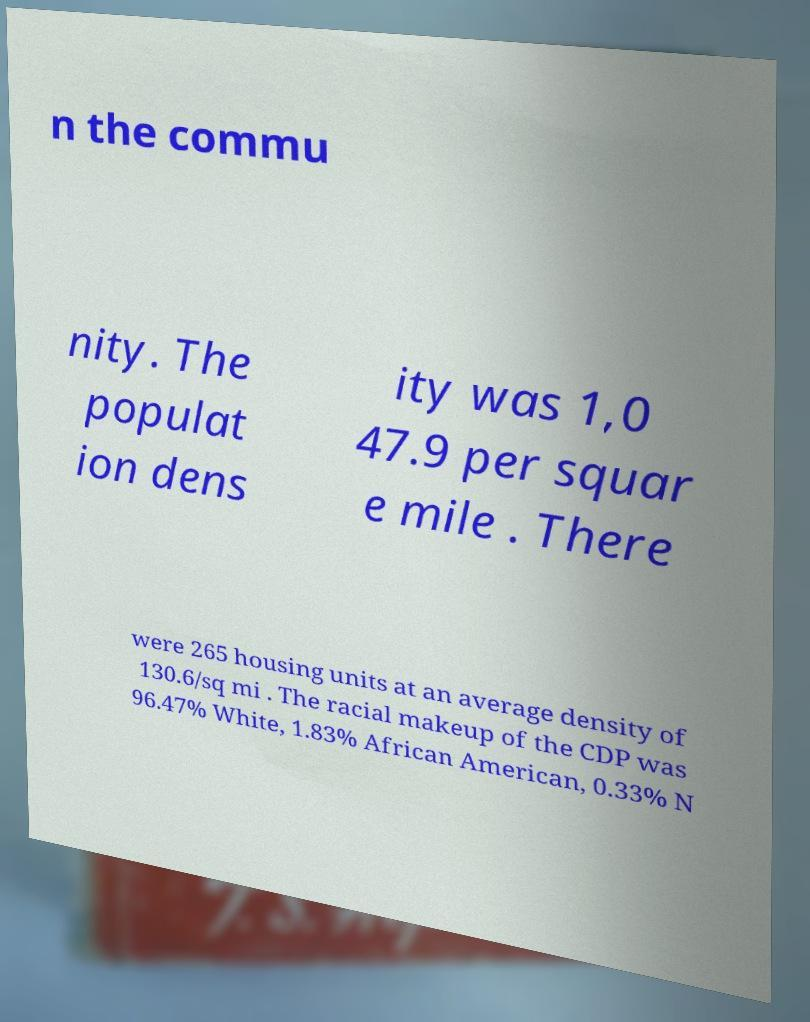Can you accurately transcribe the text from the provided image for me? n the commu nity. The populat ion dens ity was 1,0 47.9 per squar e mile . There were 265 housing units at an average density of 130.6/sq mi . The racial makeup of the CDP was 96.47% White, 1.83% African American, 0.33% N 